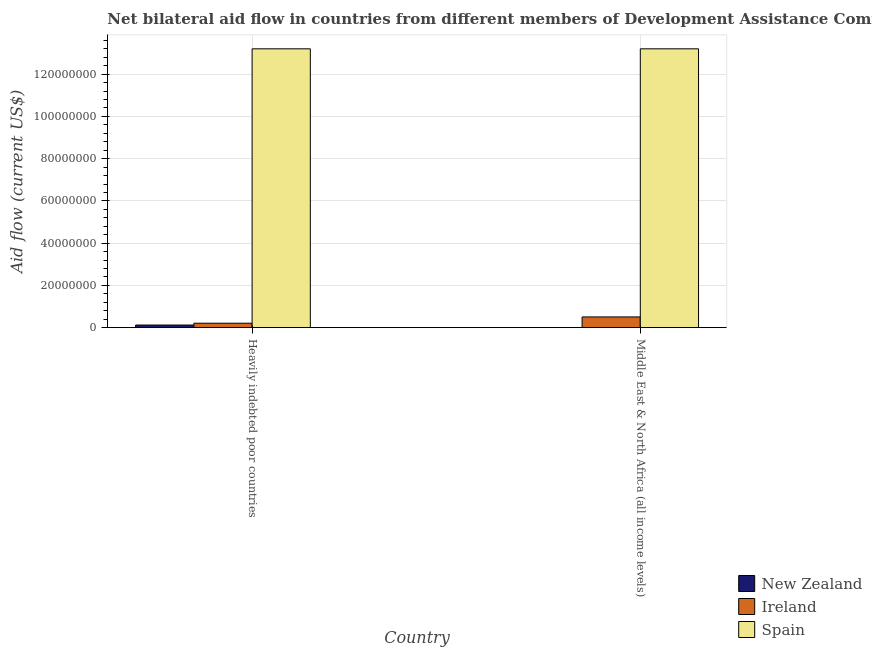How many different coloured bars are there?
Your answer should be compact. 3. How many groups of bars are there?
Give a very brief answer. 2. Are the number of bars per tick equal to the number of legend labels?
Provide a short and direct response. Yes. Are the number of bars on each tick of the X-axis equal?
Your response must be concise. Yes. How many bars are there on the 2nd tick from the left?
Your answer should be compact. 3. What is the label of the 2nd group of bars from the left?
Give a very brief answer. Middle East & North Africa (all income levels). What is the amount of aid provided by spain in Heavily indebted poor countries?
Offer a very short reply. 1.32e+08. Across all countries, what is the maximum amount of aid provided by new zealand?
Your response must be concise. 1.24e+06. Across all countries, what is the minimum amount of aid provided by ireland?
Provide a succinct answer. 2.11e+06. In which country was the amount of aid provided by new zealand maximum?
Keep it short and to the point. Heavily indebted poor countries. In which country was the amount of aid provided by new zealand minimum?
Provide a short and direct response. Middle East & North Africa (all income levels). What is the total amount of aid provided by new zealand in the graph?
Make the answer very short. 1.25e+06. What is the difference between the amount of aid provided by ireland in Heavily indebted poor countries and that in Middle East & North Africa (all income levels)?
Your answer should be very brief. -2.97e+06. What is the difference between the amount of aid provided by spain in Heavily indebted poor countries and the amount of aid provided by ireland in Middle East & North Africa (all income levels)?
Your response must be concise. 1.27e+08. What is the average amount of aid provided by spain per country?
Your answer should be very brief. 1.32e+08. What is the difference between the amount of aid provided by ireland and amount of aid provided by spain in Heavily indebted poor countries?
Offer a terse response. -1.30e+08. In how many countries, is the amount of aid provided by new zealand greater than 12000000 US$?
Keep it short and to the point. 0. What is the ratio of the amount of aid provided by spain in Heavily indebted poor countries to that in Middle East & North Africa (all income levels)?
Offer a terse response. 1. In how many countries, is the amount of aid provided by new zealand greater than the average amount of aid provided by new zealand taken over all countries?
Your answer should be compact. 1. What does the 2nd bar from the left in Middle East & North Africa (all income levels) represents?
Your answer should be very brief. Ireland. What does the 3rd bar from the right in Heavily indebted poor countries represents?
Offer a terse response. New Zealand. Is it the case that in every country, the sum of the amount of aid provided by new zealand and amount of aid provided by ireland is greater than the amount of aid provided by spain?
Your answer should be very brief. No. How many bars are there?
Your answer should be compact. 6. How many countries are there in the graph?
Provide a short and direct response. 2. Are the values on the major ticks of Y-axis written in scientific E-notation?
Offer a very short reply. No. Does the graph contain any zero values?
Your answer should be compact. No. Where does the legend appear in the graph?
Ensure brevity in your answer.  Bottom right. How many legend labels are there?
Provide a succinct answer. 3. How are the legend labels stacked?
Ensure brevity in your answer.  Vertical. What is the title of the graph?
Provide a short and direct response. Net bilateral aid flow in countries from different members of Development Assistance Committee. Does "Gaseous fuel" appear as one of the legend labels in the graph?
Provide a succinct answer. No. What is the Aid flow (current US$) of New Zealand in Heavily indebted poor countries?
Make the answer very short. 1.24e+06. What is the Aid flow (current US$) of Ireland in Heavily indebted poor countries?
Your response must be concise. 2.11e+06. What is the Aid flow (current US$) of Spain in Heavily indebted poor countries?
Provide a short and direct response. 1.32e+08. What is the Aid flow (current US$) of New Zealand in Middle East & North Africa (all income levels)?
Offer a terse response. 10000. What is the Aid flow (current US$) in Ireland in Middle East & North Africa (all income levels)?
Make the answer very short. 5.08e+06. What is the Aid flow (current US$) in Spain in Middle East & North Africa (all income levels)?
Provide a succinct answer. 1.32e+08. Across all countries, what is the maximum Aid flow (current US$) of New Zealand?
Provide a succinct answer. 1.24e+06. Across all countries, what is the maximum Aid flow (current US$) in Ireland?
Keep it short and to the point. 5.08e+06. Across all countries, what is the maximum Aid flow (current US$) of Spain?
Ensure brevity in your answer.  1.32e+08. Across all countries, what is the minimum Aid flow (current US$) of New Zealand?
Provide a succinct answer. 10000. Across all countries, what is the minimum Aid flow (current US$) of Ireland?
Provide a short and direct response. 2.11e+06. Across all countries, what is the minimum Aid flow (current US$) of Spain?
Your response must be concise. 1.32e+08. What is the total Aid flow (current US$) in New Zealand in the graph?
Your response must be concise. 1.25e+06. What is the total Aid flow (current US$) in Ireland in the graph?
Provide a succinct answer. 7.19e+06. What is the total Aid flow (current US$) of Spain in the graph?
Your answer should be very brief. 2.64e+08. What is the difference between the Aid flow (current US$) in New Zealand in Heavily indebted poor countries and that in Middle East & North Africa (all income levels)?
Keep it short and to the point. 1.23e+06. What is the difference between the Aid flow (current US$) of Ireland in Heavily indebted poor countries and that in Middle East & North Africa (all income levels)?
Provide a short and direct response. -2.97e+06. What is the difference between the Aid flow (current US$) of Spain in Heavily indebted poor countries and that in Middle East & North Africa (all income levels)?
Keep it short and to the point. 0. What is the difference between the Aid flow (current US$) of New Zealand in Heavily indebted poor countries and the Aid flow (current US$) of Ireland in Middle East & North Africa (all income levels)?
Provide a short and direct response. -3.84e+06. What is the difference between the Aid flow (current US$) in New Zealand in Heavily indebted poor countries and the Aid flow (current US$) in Spain in Middle East & North Africa (all income levels)?
Offer a very short reply. -1.31e+08. What is the difference between the Aid flow (current US$) in Ireland in Heavily indebted poor countries and the Aid flow (current US$) in Spain in Middle East & North Africa (all income levels)?
Make the answer very short. -1.30e+08. What is the average Aid flow (current US$) in New Zealand per country?
Provide a succinct answer. 6.25e+05. What is the average Aid flow (current US$) of Ireland per country?
Provide a succinct answer. 3.60e+06. What is the average Aid flow (current US$) in Spain per country?
Make the answer very short. 1.32e+08. What is the difference between the Aid flow (current US$) of New Zealand and Aid flow (current US$) of Ireland in Heavily indebted poor countries?
Ensure brevity in your answer.  -8.70e+05. What is the difference between the Aid flow (current US$) of New Zealand and Aid flow (current US$) of Spain in Heavily indebted poor countries?
Offer a very short reply. -1.31e+08. What is the difference between the Aid flow (current US$) of Ireland and Aid flow (current US$) of Spain in Heavily indebted poor countries?
Your response must be concise. -1.30e+08. What is the difference between the Aid flow (current US$) of New Zealand and Aid flow (current US$) of Ireland in Middle East & North Africa (all income levels)?
Make the answer very short. -5.07e+06. What is the difference between the Aid flow (current US$) in New Zealand and Aid flow (current US$) in Spain in Middle East & North Africa (all income levels)?
Provide a succinct answer. -1.32e+08. What is the difference between the Aid flow (current US$) in Ireland and Aid flow (current US$) in Spain in Middle East & North Africa (all income levels)?
Offer a very short reply. -1.27e+08. What is the ratio of the Aid flow (current US$) in New Zealand in Heavily indebted poor countries to that in Middle East & North Africa (all income levels)?
Make the answer very short. 124. What is the ratio of the Aid flow (current US$) of Ireland in Heavily indebted poor countries to that in Middle East & North Africa (all income levels)?
Give a very brief answer. 0.42. What is the ratio of the Aid flow (current US$) in Spain in Heavily indebted poor countries to that in Middle East & North Africa (all income levels)?
Ensure brevity in your answer.  1. What is the difference between the highest and the second highest Aid flow (current US$) of New Zealand?
Offer a terse response. 1.23e+06. What is the difference between the highest and the second highest Aid flow (current US$) in Ireland?
Give a very brief answer. 2.97e+06. What is the difference between the highest and the lowest Aid flow (current US$) of New Zealand?
Offer a terse response. 1.23e+06. What is the difference between the highest and the lowest Aid flow (current US$) of Ireland?
Give a very brief answer. 2.97e+06. 